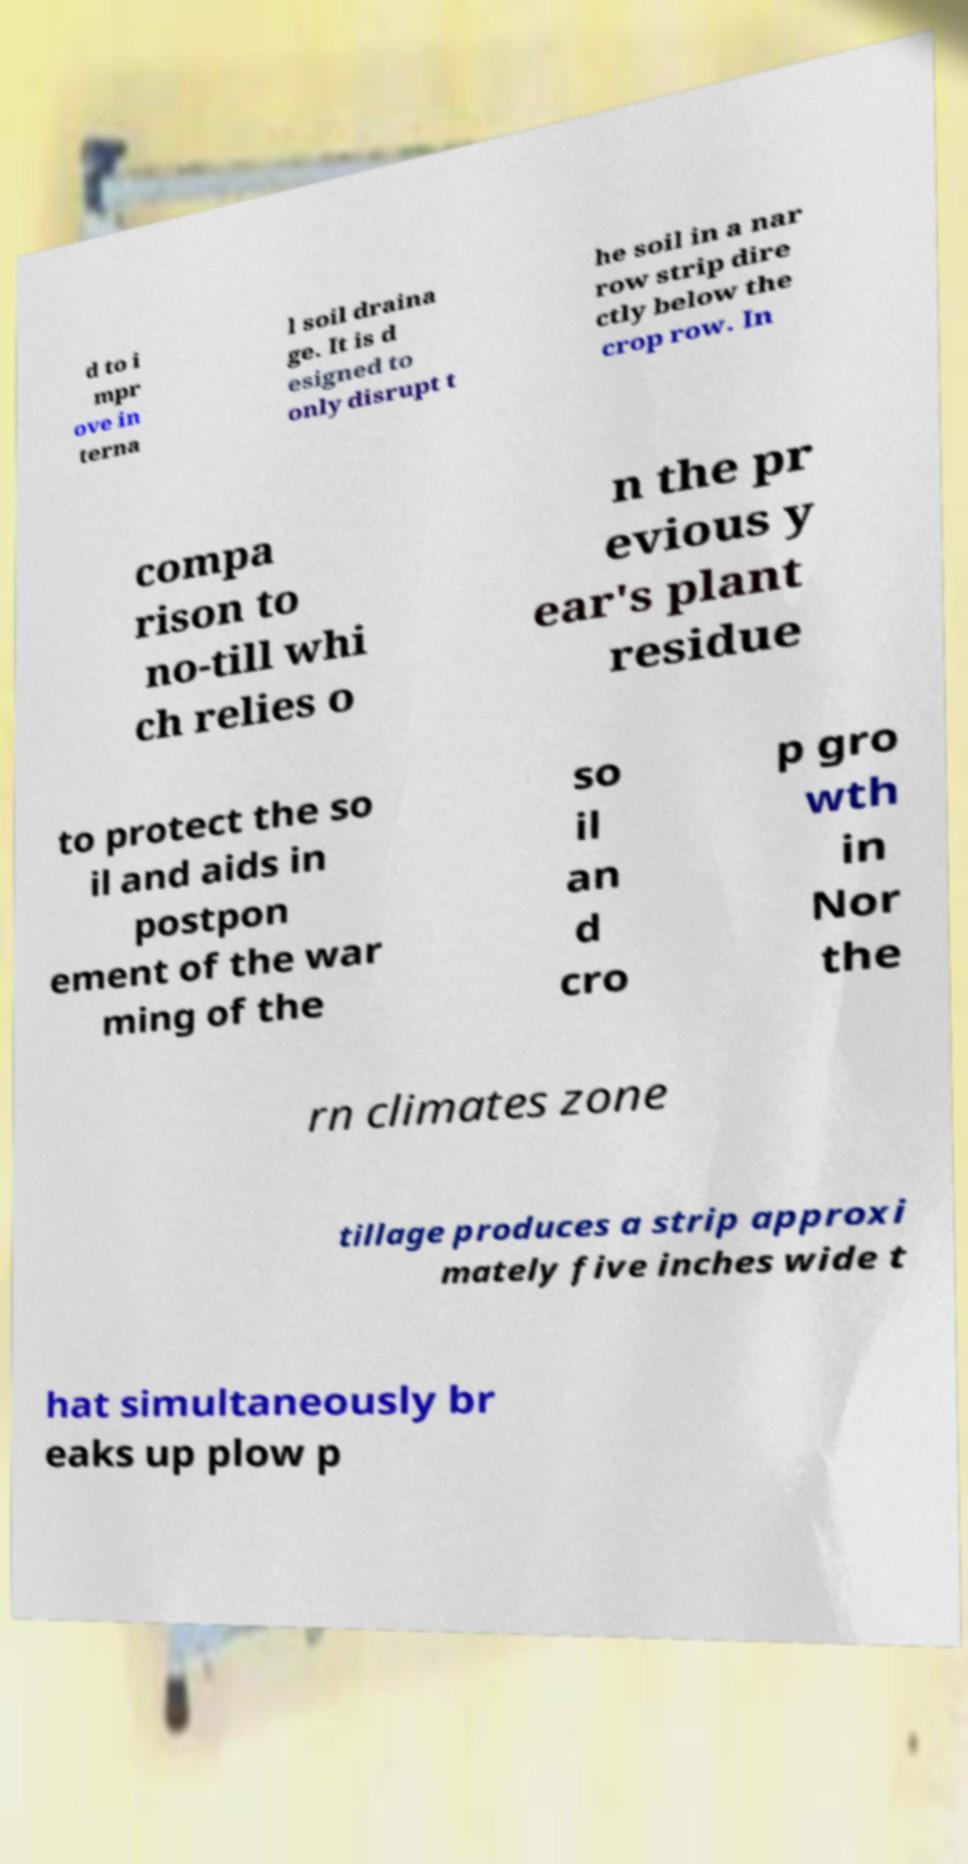What messages or text are displayed in this image? I need them in a readable, typed format. d to i mpr ove in terna l soil draina ge. It is d esigned to only disrupt t he soil in a nar row strip dire ctly below the crop row. In compa rison to no-till whi ch relies o n the pr evious y ear's plant residue to protect the so il and aids in postpon ement of the war ming of the so il an d cro p gro wth in Nor the rn climates zone tillage produces a strip approxi mately five inches wide t hat simultaneously br eaks up plow p 